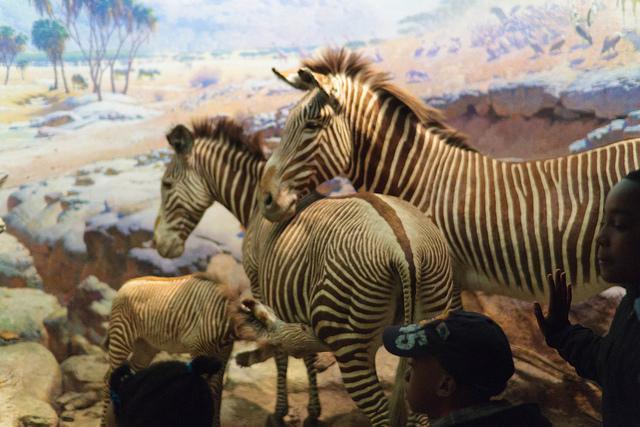How many zebras are there?
Give a very brief answer. 3. How many people are in the picture?
Give a very brief answer. 3. 